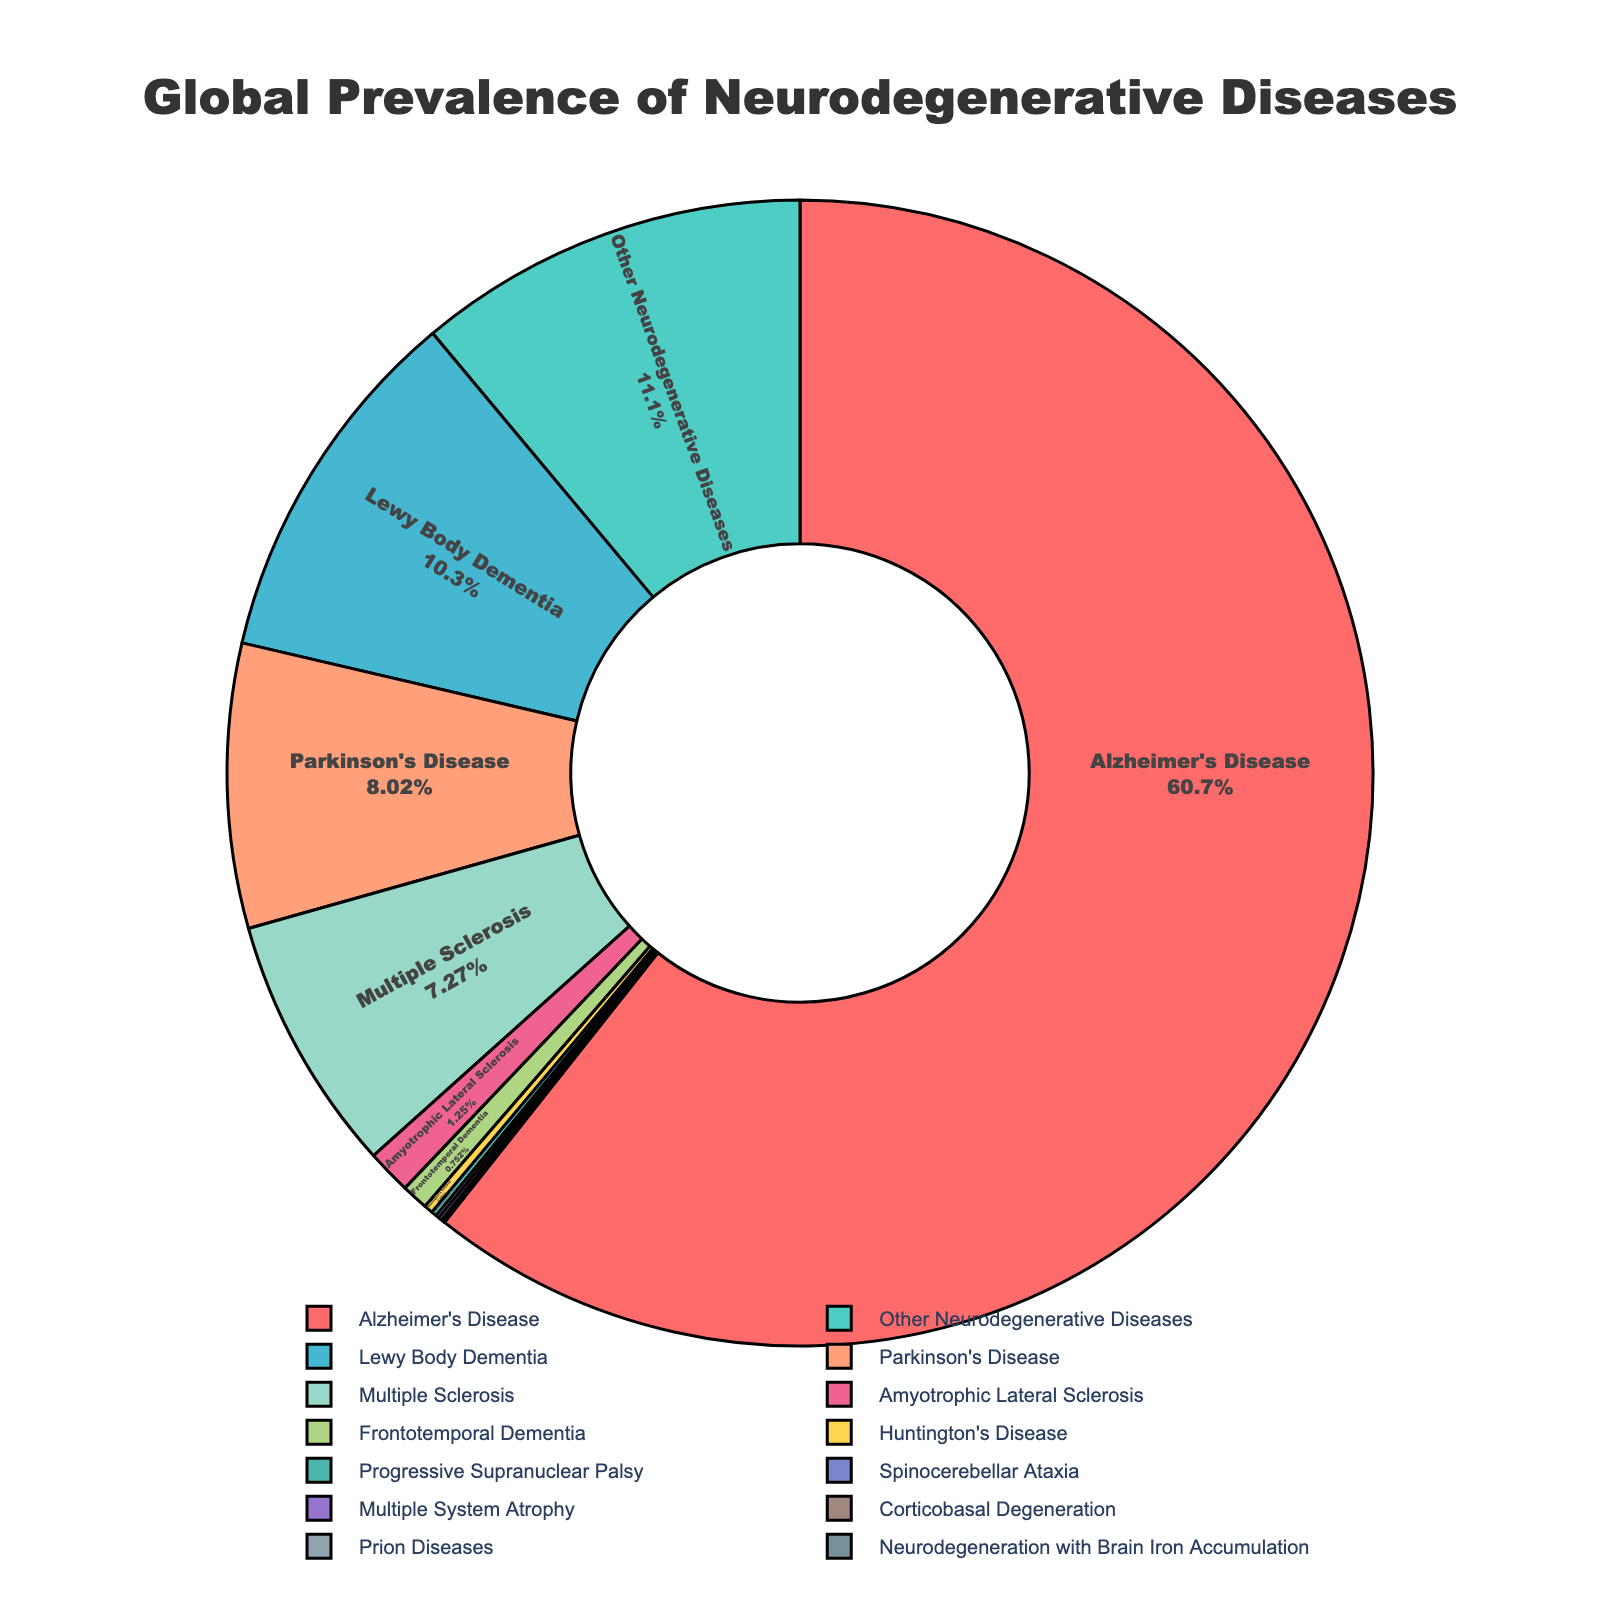what is the most prevalent neurodegenerative disease? The pie chart shows that Alzheimer's Disease has the largest section, indicating it has the highest prevalence.
Answer: Alzheimer's Disease which disease has a higher prevalence, Parkinson's Disease or Multiple System Atrophy? Comparing the sections on the pie chart for the two diseases, Parkinson's Disease has a larger section than Multiple System Atrophy.
Answer: Parkinson's Disease what is the combined prevalence of Parkinson's Disease and Lewy Body Dementia? The prevalence of Parkinson's Disease is 0.32% and the prevalence of Lewy Body Dementia is 0.41%. Adding these gives 0.32% + 0.41% = 0.73%.
Answer: 0.73% how does the prevalence of Alzheimer's Disease compare to Prion Diseases? The pie chart shows that Alzheimer's Disease has a much larger section compared to Prion Diseases, indicating a significantly higher prevalence.
Answer: Much higher which diseases have a prevalence less than 0.01%? The diseases with sections indicating less than 0.01% prevalence are Prion Diseases, Spinocerebellar Ataxia, Corticobasal Degeneration, and Neurodegeneration with Brain Iron Accumulation.
Answer: Prion Diseases, Spinocerebellar Ataxia, Corticobasal Degeneration, Neurodegeneration with Brain Iron Accumulation what is the total prevalence of all diseases with a prevalence above 0.4%? The diseases with prevalence above 0.4% are Alzheimer's Disease (2.42%) and Lewy Body Dementia (0.41%). Adding these gives 2.42% + 0.41% = 2.83%.
Answer: 2.83% if we exclude Alzheimer's Disease, which disease is the next most prevalent? The pie chart shows that after Alzheimer's Disease, the largest section belongs to "Other Neurodegenerative Diseases" with 0.442% prevalence.
Answer: Other Neurodegenerative Diseases what is the difference in prevalence between Multiple Sclerosis and Huntington's Disease? The prevalence of Multiple Sclerosis is 0.29% and the prevalence of Huntington's Disease is 0.01%. The difference is 0.29% - 0.01% = 0.28%.
Answer: 0.28% how many diseases have a prevalence between 0.01% and 0.1%? The diseases with prevalence in this range are Amyotrophic Lateral Sclerosis (0.05%), Frontotemporal Dementia (0.03%), Spinocerebellar Ataxia (0.004%), and Multiple System Atrophy (0.004%).
Answer: 4 